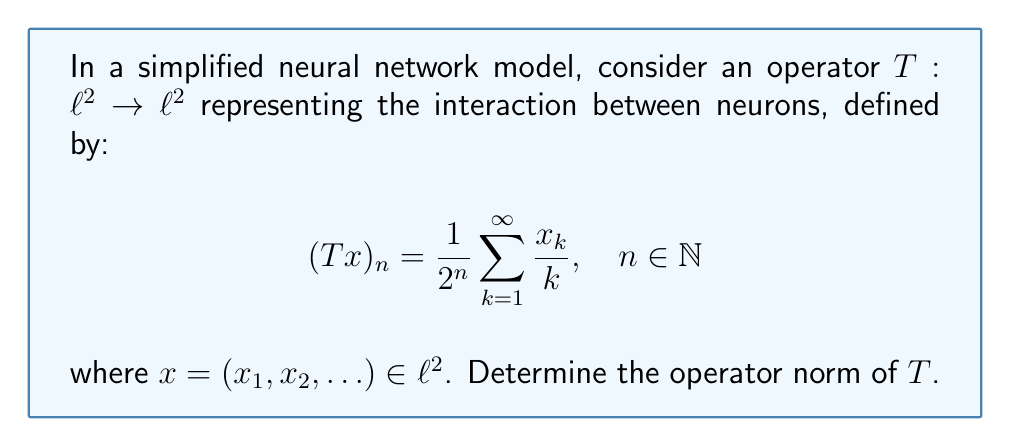Can you answer this question? To find the operator norm of $T$, we'll follow these steps:

1) First, recall that for an operator $T: \ell^2 \rightarrow \ell^2$, the operator norm is defined as:

   $$\|T\| = \sup_{x \neq 0} \frac{\|Tx\|}{\|x\|} = \sup_{\|x\|=1} \|Tx\|$$

2) We need to find an upper bound for $\|Tx\|$ when $\|x\| = 1$.

3) Let's start by applying the Cauchy-Schwarz inequality:

   $$|(Tx)_n| = \left|\frac{1}{2^n}\sum_{k=1}^{\infty} \frac{x_k}{k}\right| \leq \frac{1}{2^n}\left(\sum_{k=1}^{\infty} \frac{1}{k^2}\right)^{1/2}\left(\sum_{k=1}^{\infty} |x_k|^2\right)^{1/2}$$

4) We know that $\sum_{k=1}^{\infty} \frac{1}{k^2} = \frac{\pi^2}{6}$, and since $\|x\| = 1$, we have $\sum_{k=1}^{\infty} |x_k|^2 = 1$. Thus:

   $$|(Tx)_n| \leq \frac{1}{2^n} \sqrt{\frac{\pi^2}{6}}$$

5) Now, we can compute $\|Tx\|^2$:

   $$\|Tx\|^2 = \sum_{n=1}^{\infty} |(Tx)_n|^2 \leq \sum_{n=1}^{\infty} \frac{\pi^2}{6 \cdot 4^n} = \frac{\pi^2}{6} \sum_{n=1}^{\infty} \frac{1}{4^n} = \frac{\pi^2}{6} \cdot \frac{1/4}{1-1/4} = \frac{\pi^2}{18}$$

6) Therefore, $\|Tx\| \leq \frac{\pi}{3\sqrt{2}}$ for all $x$ with $\|x\| = 1$.

7) To show that this upper bound is actually achieved, consider the sequence $y = (y_1, y_2, \ldots)$ where $y_k = \frac{\sqrt{6}}{\pi k}$. Note that $\|y\| = 1$.

8) For this $y$, we have:

   $$(Ty)_n = \frac{1}{2^n}\sum_{k=1}^{\infty} \frac{y_k}{k} = \frac{1}{2^n}\sum_{k=1}^{\infty} \frac{\sqrt{6}}{\pi k^2} = \frac{\sqrt{6}}{2^n \pi} \cdot \frac{\pi^2}{6} = \frac{\pi}{3\sqrt{2}} \cdot \frac{1}{2^n}$$

9) Computing $\|Ty\|^2$:

   $$\|Ty\|^2 = \sum_{n=1}^{\infty} |(Ty)_n|^2 = \left(\frac{\pi}{3\sqrt{2}}\right)^2 \sum_{n=1}^{\infty} \frac{1}{4^n} = \left(\frac{\pi}{3\sqrt{2}}\right)^2 \cdot \frac{1/4}{1-1/4} = \frac{\pi^2}{18}$$

Thus, $\|Ty\| = \frac{\pi}{3\sqrt{2}}$, which matches our upper bound.
Answer: The operator norm of $T$ is $\|T\| = \frac{\pi}{3\sqrt{2}}$. 